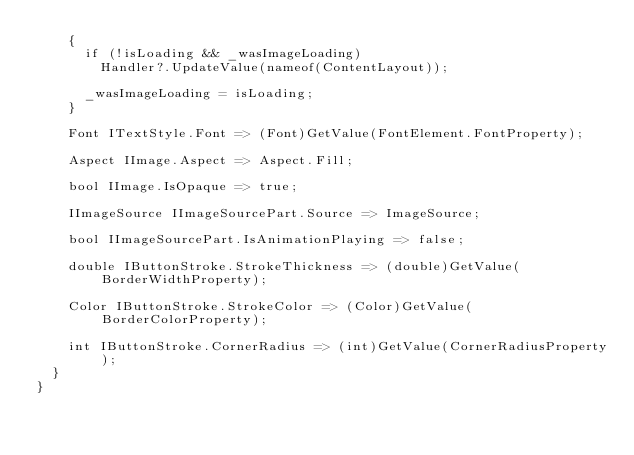<code> <loc_0><loc_0><loc_500><loc_500><_C#_>		{
			if (!isLoading && _wasImageLoading)
				Handler?.UpdateValue(nameof(ContentLayout));

			_wasImageLoading = isLoading;
		}

		Font ITextStyle.Font => (Font)GetValue(FontElement.FontProperty);

		Aspect IImage.Aspect => Aspect.Fill;

		bool IImage.IsOpaque => true;

		IImageSource IImageSourcePart.Source => ImageSource;

		bool IImageSourcePart.IsAnimationPlaying => false;

		double IButtonStroke.StrokeThickness => (double)GetValue(BorderWidthProperty);

		Color IButtonStroke.StrokeColor => (Color)GetValue(BorderColorProperty);

		int IButtonStroke.CornerRadius => (int)GetValue(CornerRadiusProperty);
	}
}</code> 